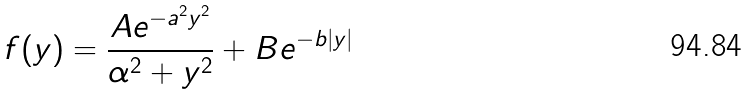Convert formula to latex. <formula><loc_0><loc_0><loc_500><loc_500>f ( y ) = \frac { A e ^ { - a ^ { 2 } y ^ { 2 } } } { \alpha ^ { 2 } + y ^ { 2 } } + B e ^ { - b | y | }</formula> 